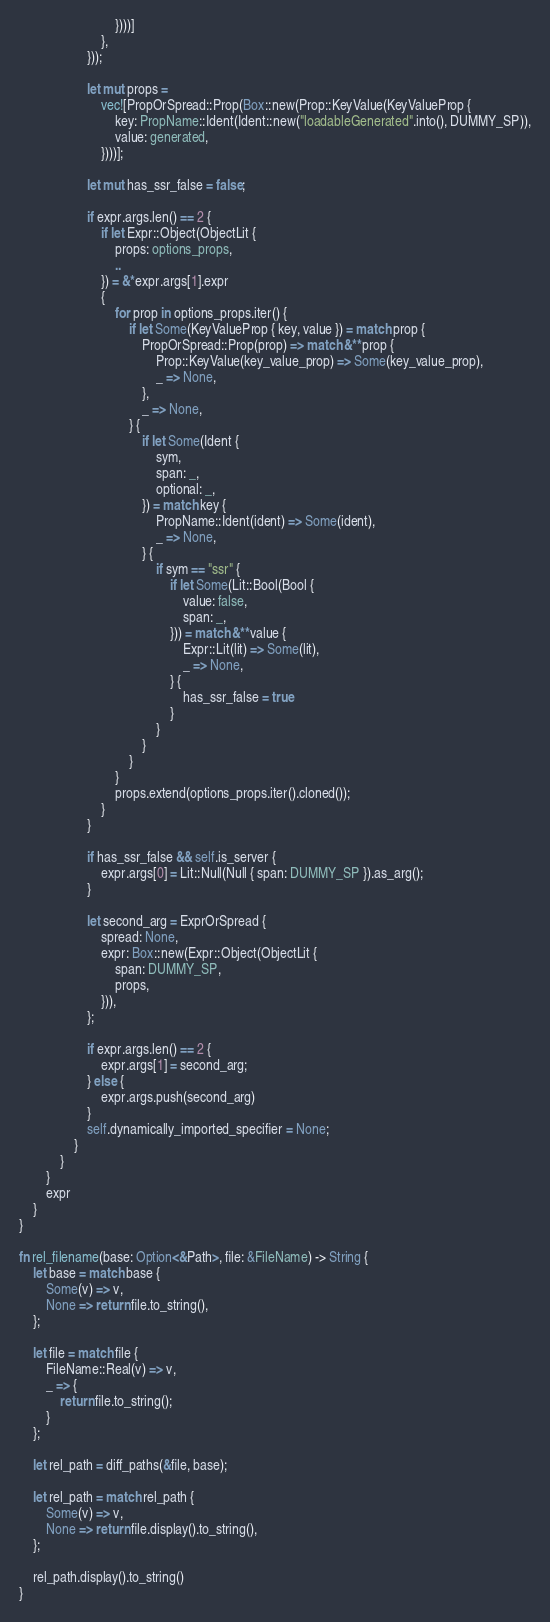<code> <loc_0><loc_0><loc_500><loc_500><_Rust_>                            })))]
                        },
                    }));

                    let mut props =
                        vec![PropOrSpread::Prop(Box::new(Prop::KeyValue(KeyValueProp {
                            key: PropName::Ident(Ident::new("loadableGenerated".into(), DUMMY_SP)),
                            value: generated,
                        })))];

                    let mut has_ssr_false = false;

                    if expr.args.len() == 2 {
                        if let Expr::Object(ObjectLit {
                            props: options_props,
                            ..
                        }) = &*expr.args[1].expr
                        {
                            for prop in options_props.iter() {
                                if let Some(KeyValueProp { key, value }) = match prop {
                                    PropOrSpread::Prop(prop) => match &**prop {
                                        Prop::KeyValue(key_value_prop) => Some(key_value_prop),
                                        _ => None,
                                    },
                                    _ => None,
                                } {
                                    if let Some(Ident {
                                        sym,
                                        span: _,
                                        optional: _,
                                    }) = match key {
                                        PropName::Ident(ident) => Some(ident),
                                        _ => None,
                                    } {
                                        if sym == "ssr" {
                                            if let Some(Lit::Bool(Bool {
                                                value: false,
                                                span: _,
                                            })) = match &**value {
                                                Expr::Lit(lit) => Some(lit),
                                                _ => None,
                                            } {
                                                has_ssr_false = true
                                            }
                                        }
                                    }
                                }
                            }
                            props.extend(options_props.iter().cloned());
                        }
                    }

                    if has_ssr_false && self.is_server {
                        expr.args[0] = Lit::Null(Null { span: DUMMY_SP }).as_arg();
                    }

                    let second_arg = ExprOrSpread {
                        spread: None,
                        expr: Box::new(Expr::Object(ObjectLit {
                            span: DUMMY_SP,
                            props,
                        })),
                    };

                    if expr.args.len() == 2 {
                        expr.args[1] = second_arg;
                    } else {
                        expr.args.push(second_arg)
                    }
                    self.dynamically_imported_specifier = None;
                }
            }
        }
        expr
    }
}

fn rel_filename(base: Option<&Path>, file: &FileName) -> String {
    let base = match base {
        Some(v) => v,
        None => return file.to_string(),
    };

    let file = match file {
        FileName::Real(v) => v,
        _ => {
            return file.to_string();
        }
    };

    let rel_path = diff_paths(&file, base);

    let rel_path = match rel_path {
        Some(v) => v,
        None => return file.display().to_string(),
    };

    rel_path.display().to_string()
}
</code> 